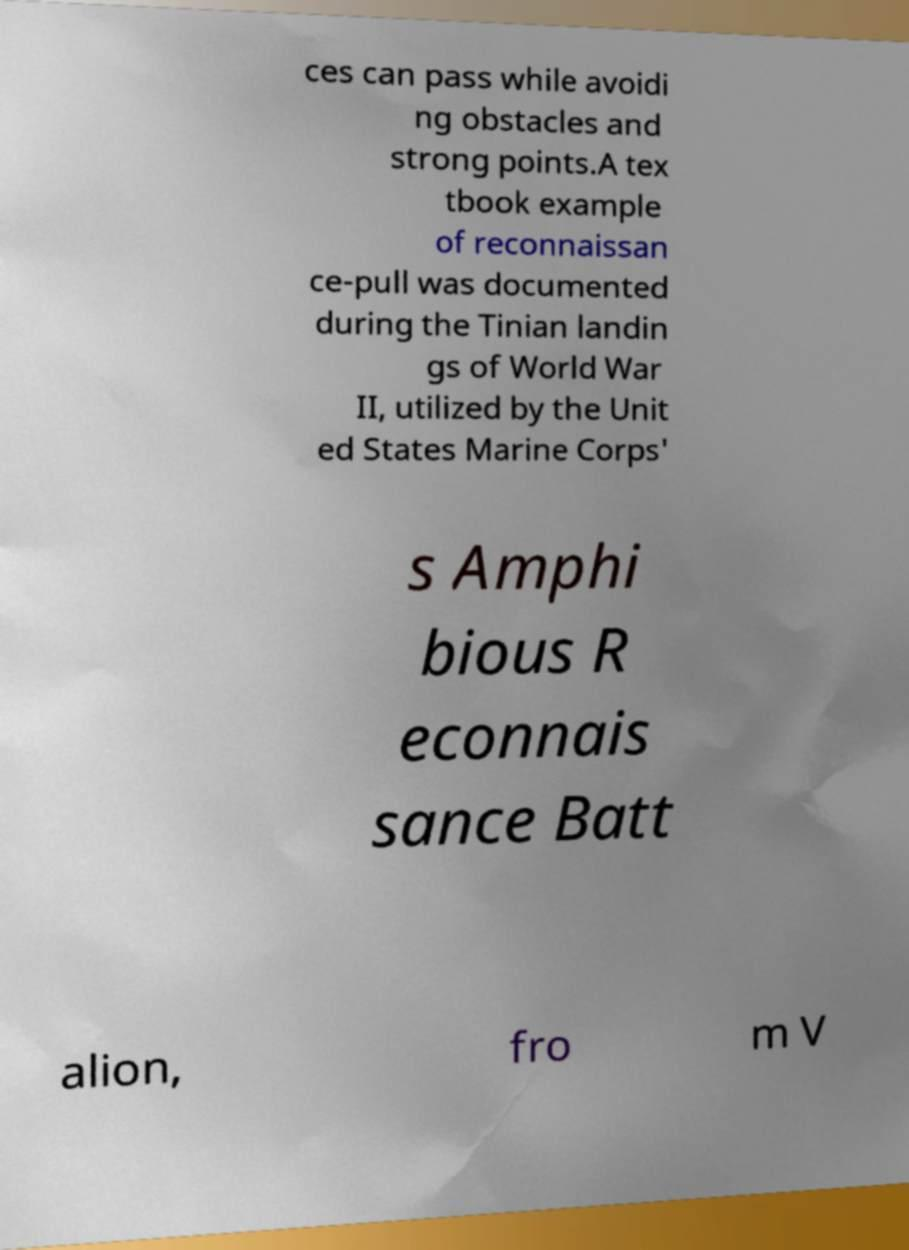For documentation purposes, I need the text within this image transcribed. Could you provide that? ces can pass while avoidi ng obstacles and strong points.A tex tbook example of reconnaissan ce-pull was documented during the Tinian landin gs of World War II, utilized by the Unit ed States Marine Corps' s Amphi bious R econnais sance Batt alion, fro m V 